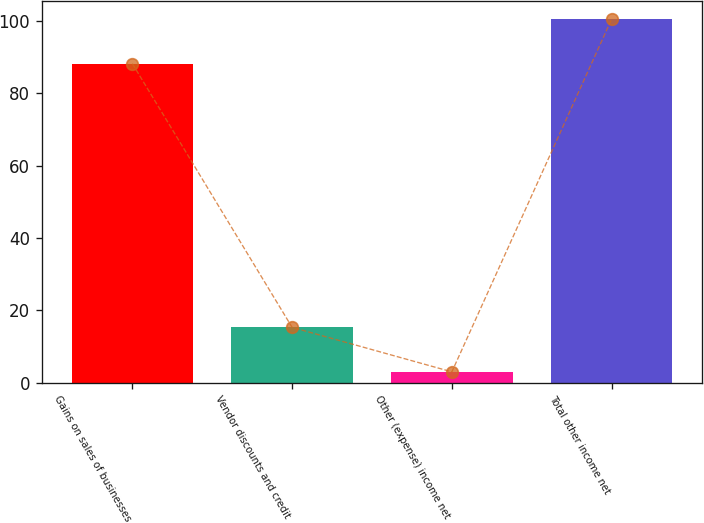Convert chart. <chart><loc_0><loc_0><loc_500><loc_500><bar_chart><fcel>Gains on sales of businesses<fcel>Vendor discounts and credit<fcel>Other (expense) income net<fcel>Total other income net<nl><fcel>88.2<fcel>15.3<fcel>3<fcel>100.5<nl></chart> 